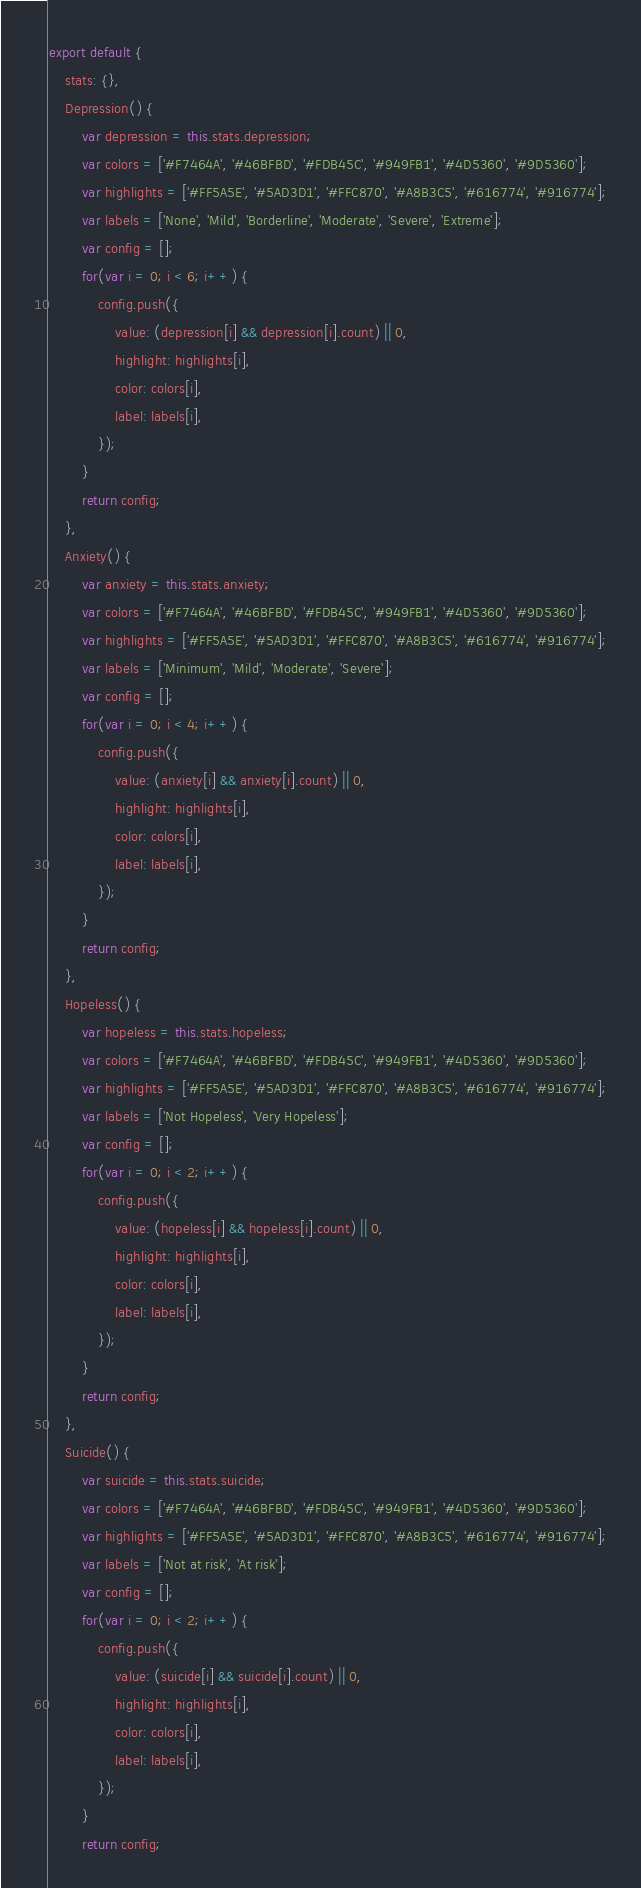<code> <loc_0><loc_0><loc_500><loc_500><_JavaScript_>export default {
	stats: {},
	Depression() {
		var depression = this.stats.depression;
		var colors = ['#F7464A', '#46BFBD', '#FDB45C', '#949FB1', '#4D5360', '#9D5360'];
		var highlights = ['#FF5A5E', '#5AD3D1', '#FFC870', '#A8B3C5', '#616774', '#916774'];
		var labels = ['None', 'Mild', 'Borderline', 'Moderate', 'Severe', 'Extreme'];
		var config = [];
		for(var i = 0; i < 6; i++) {
			config.push({
				value: (depression[i] && depression[i].count) || 0,
				highlight: highlights[i],
				color: colors[i],
				label: labels[i],
			});
		}
		return config;
	},
	Anxiety() {
		var anxiety = this.stats.anxiety;
		var colors = ['#F7464A', '#46BFBD', '#FDB45C', '#949FB1', '#4D5360', '#9D5360'];
		var highlights = ['#FF5A5E', '#5AD3D1', '#FFC870', '#A8B3C5', '#616774', '#916774'];
		var labels = ['Minimum', 'Mild', 'Moderate', 'Severe'];
		var config = [];
		for(var i = 0; i < 4; i++) {
			config.push({
				value: (anxiety[i] && anxiety[i].count) || 0,
				highlight: highlights[i],
				color: colors[i],
				label: labels[i],
			});
		}
		return config;
	},
	Hopeless() {
		var hopeless = this.stats.hopeless;
		var colors = ['#F7464A', '#46BFBD', '#FDB45C', '#949FB1', '#4D5360', '#9D5360'];
		var highlights = ['#FF5A5E', '#5AD3D1', '#FFC870', '#A8B3C5', '#616774', '#916774'];
		var labels = ['Not Hopeless', 'Very Hopeless'];
		var config = [];
		for(var i = 0; i < 2; i++) {
			config.push({
				value: (hopeless[i] && hopeless[i].count) || 0,
				highlight: highlights[i],
				color: colors[i],
				label: labels[i],
			});
		}
		return config;
	},
	Suicide() {
		var suicide = this.stats.suicide;
		var colors = ['#F7464A', '#46BFBD', '#FDB45C', '#949FB1', '#4D5360', '#9D5360'];
		var highlights = ['#FF5A5E', '#5AD3D1', '#FFC870', '#A8B3C5', '#616774', '#916774'];
		var labels = ['Not at risk', 'At risk'];
		var config = [];
		for(var i = 0; i < 2; i++) {
			config.push({
				value: (suicide[i] && suicide[i].count) || 0,
				highlight: highlights[i],
				color: colors[i],
				label: labels[i],
			});
		}
		return config;</code> 